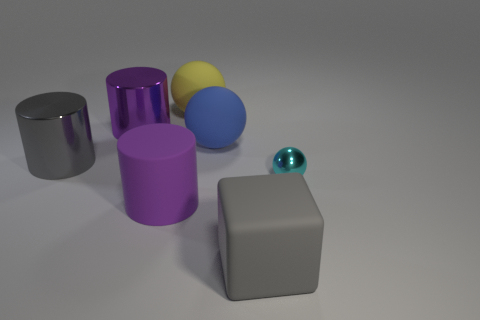Is there any other thing that has the same shape as the gray rubber object?
Give a very brief answer. No. Are there any other things that have the same size as the cyan sphere?
Your response must be concise. No. There is a gray matte block; is it the same size as the ball on the right side of the big gray rubber object?
Provide a succinct answer. No. What size is the ball that is on the right side of the large gray thing on the right side of the large matte ball in front of the purple shiny cylinder?
Provide a succinct answer. Small. What number of objects are matte things in front of the purple matte cylinder or big yellow things?
Provide a short and direct response. 2. What number of big rubber objects are behind the gray thing that is behind the large gray rubber cube?
Your answer should be very brief. 2. Is the number of cubes right of the purple matte cylinder greater than the number of tiny green metallic things?
Give a very brief answer. Yes. There is a object that is both behind the rubber cube and right of the blue ball; how big is it?
Make the answer very short. Small. There is a big thing that is behind the blue rubber ball and left of the yellow rubber ball; what shape is it?
Your response must be concise. Cylinder. There is a big rubber sphere behind the purple cylinder that is behind the small metallic ball; are there any large purple metallic cylinders in front of it?
Offer a terse response. Yes. 